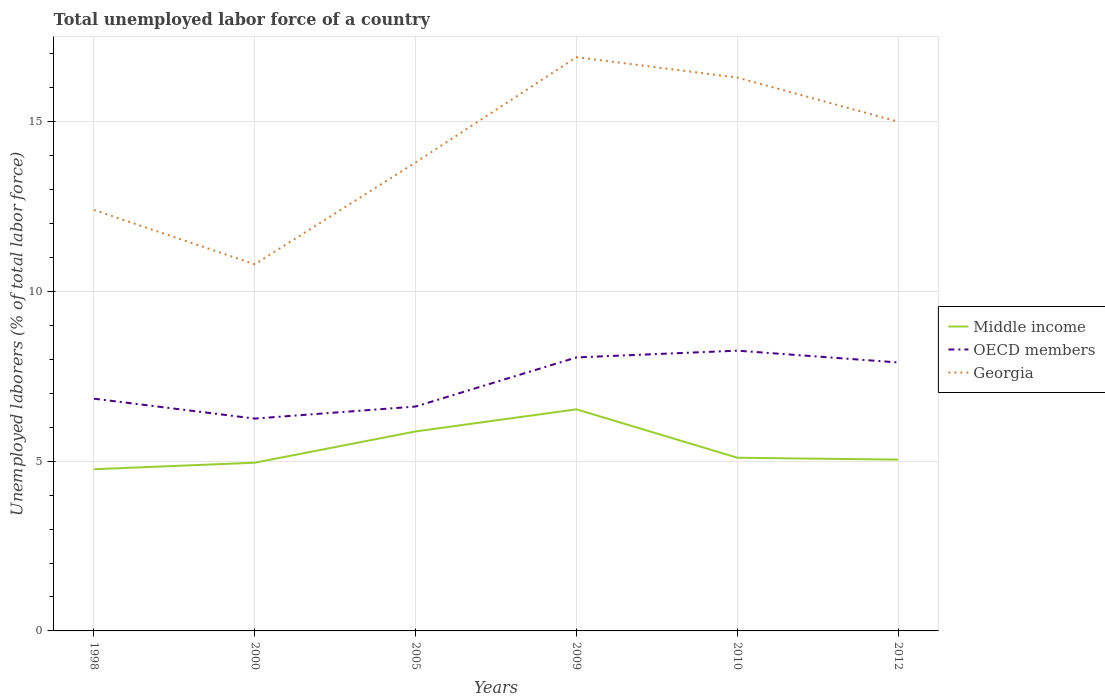Does the line corresponding to OECD members intersect with the line corresponding to Middle income?
Offer a terse response. No. Is the number of lines equal to the number of legend labels?
Make the answer very short. Yes. Across all years, what is the maximum total unemployed labor force in Middle income?
Offer a terse response. 4.76. What is the total total unemployed labor force in Georgia in the graph?
Your answer should be compact. -5.5. What is the difference between the highest and the second highest total unemployed labor force in Middle income?
Offer a terse response. 1.76. What is the difference between two consecutive major ticks on the Y-axis?
Make the answer very short. 5. Are the values on the major ticks of Y-axis written in scientific E-notation?
Your response must be concise. No. Does the graph contain any zero values?
Give a very brief answer. No. How are the legend labels stacked?
Keep it short and to the point. Vertical. What is the title of the graph?
Give a very brief answer. Total unemployed labor force of a country. What is the label or title of the Y-axis?
Ensure brevity in your answer.  Unemployed laborers (% of total labor force). What is the Unemployed laborers (% of total labor force) in Middle income in 1998?
Your answer should be very brief. 4.76. What is the Unemployed laborers (% of total labor force) of OECD members in 1998?
Your response must be concise. 6.84. What is the Unemployed laborers (% of total labor force) of Georgia in 1998?
Provide a succinct answer. 12.4. What is the Unemployed laborers (% of total labor force) of Middle income in 2000?
Give a very brief answer. 4.96. What is the Unemployed laborers (% of total labor force) of OECD members in 2000?
Keep it short and to the point. 6.25. What is the Unemployed laborers (% of total labor force) in Georgia in 2000?
Make the answer very short. 10.8. What is the Unemployed laborers (% of total labor force) in Middle income in 2005?
Offer a terse response. 5.88. What is the Unemployed laborers (% of total labor force) of OECD members in 2005?
Keep it short and to the point. 6.61. What is the Unemployed laborers (% of total labor force) in Georgia in 2005?
Provide a short and direct response. 13.8. What is the Unemployed laborers (% of total labor force) in Middle income in 2009?
Ensure brevity in your answer.  6.53. What is the Unemployed laborers (% of total labor force) in OECD members in 2009?
Ensure brevity in your answer.  8.06. What is the Unemployed laborers (% of total labor force) in Georgia in 2009?
Give a very brief answer. 16.9. What is the Unemployed laborers (% of total labor force) of Middle income in 2010?
Your response must be concise. 5.1. What is the Unemployed laborers (% of total labor force) in OECD members in 2010?
Your response must be concise. 8.26. What is the Unemployed laborers (% of total labor force) in Georgia in 2010?
Offer a very short reply. 16.3. What is the Unemployed laborers (% of total labor force) in Middle income in 2012?
Offer a terse response. 5.05. What is the Unemployed laborers (% of total labor force) in OECD members in 2012?
Ensure brevity in your answer.  7.91. What is the Unemployed laborers (% of total labor force) in Georgia in 2012?
Your response must be concise. 15. Across all years, what is the maximum Unemployed laborers (% of total labor force) in Middle income?
Provide a short and direct response. 6.53. Across all years, what is the maximum Unemployed laborers (% of total labor force) in OECD members?
Provide a succinct answer. 8.26. Across all years, what is the maximum Unemployed laborers (% of total labor force) of Georgia?
Provide a succinct answer. 16.9. Across all years, what is the minimum Unemployed laborers (% of total labor force) of Middle income?
Ensure brevity in your answer.  4.76. Across all years, what is the minimum Unemployed laborers (% of total labor force) in OECD members?
Make the answer very short. 6.25. Across all years, what is the minimum Unemployed laborers (% of total labor force) of Georgia?
Provide a succinct answer. 10.8. What is the total Unemployed laborers (% of total labor force) of Middle income in the graph?
Your answer should be very brief. 32.27. What is the total Unemployed laborers (% of total labor force) in OECD members in the graph?
Offer a terse response. 43.92. What is the total Unemployed laborers (% of total labor force) in Georgia in the graph?
Give a very brief answer. 85.2. What is the difference between the Unemployed laborers (% of total labor force) in Middle income in 1998 and that in 2000?
Give a very brief answer. -0.19. What is the difference between the Unemployed laborers (% of total labor force) of OECD members in 1998 and that in 2000?
Make the answer very short. 0.59. What is the difference between the Unemployed laborers (% of total labor force) of Middle income in 1998 and that in 2005?
Make the answer very short. -1.11. What is the difference between the Unemployed laborers (% of total labor force) in OECD members in 1998 and that in 2005?
Offer a very short reply. 0.23. What is the difference between the Unemployed laborers (% of total labor force) in Georgia in 1998 and that in 2005?
Give a very brief answer. -1.4. What is the difference between the Unemployed laborers (% of total labor force) in Middle income in 1998 and that in 2009?
Make the answer very short. -1.76. What is the difference between the Unemployed laborers (% of total labor force) in OECD members in 1998 and that in 2009?
Provide a succinct answer. -1.22. What is the difference between the Unemployed laborers (% of total labor force) of Middle income in 1998 and that in 2010?
Give a very brief answer. -0.34. What is the difference between the Unemployed laborers (% of total labor force) in OECD members in 1998 and that in 2010?
Offer a terse response. -1.41. What is the difference between the Unemployed laborers (% of total labor force) of Middle income in 1998 and that in 2012?
Offer a very short reply. -0.28. What is the difference between the Unemployed laborers (% of total labor force) in OECD members in 1998 and that in 2012?
Provide a short and direct response. -1.07. What is the difference between the Unemployed laborers (% of total labor force) of Middle income in 2000 and that in 2005?
Provide a succinct answer. -0.92. What is the difference between the Unemployed laborers (% of total labor force) of OECD members in 2000 and that in 2005?
Make the answer very short. -0.35. What is the difference between the Unemployed laborers (% of total labor force) in Georgia in 2000 and that in 2005?
Ensure brevity in your answer.  -3. What is the difference between the Unemployed laborers (% of total labor force) in Middle income in 2000 and that in 2009?
Provide a short and direct response. -1.57. What is the difference between the Unemployed laborers (% of total labor force) in OECD members in 2000 and that in 2009?
Offer a terse response. -1.8. What is the difference between the Unemployed laborers (% of total labor force) in Middle income in 2000 and that in 2010?
Offer a terse response. -0.15. What is the difference between the Unemployed laborers (% of total labor force) in OECD members in 2000 and that in 2010?
Offer a very short reply. -2. What is the difference between the Unemployed laborers (% of total labor force) in Middle income in 2000 and that in 2012?
Your answer should be very brief. -0.09. What is the difference between the Unemployed laborers (% of total labor force) in OECD members in 2000 and that in 2012?
Your answer should be compact. -1.65. What is the difference between the Unemployed laborers (% of total labor force) of Georgia in 2000 and that in 2012?
Provide a short and direct response. -4.2. What is the difference between the Unemployed laborers (% of total labor force) of Middle income in 2005 and that in 2009?
Your answer should be very brief. -0.65. What is the difference between the Unemployed laborers (% of total labor force) of OECD members in 2005 and that in 2009?
Ensure brevity in your answer.  -1.45. What is the difference between the Unemployed laborers (% of total labor force) of Georgia in 2005 and that in 2009?
Ensure brevity in your answer.  -3.1. What is the difference between the Unemployed laborers (% of total labor force) in Middle income in 2005 and that in 2010?
Give a very brief answer. 0.77. What is the difference between the Unemployed laborers (% of total labor force) of OECD members in 2005 and that in 2010?
Ensure brevity in your answer.  -1.65. What is the difference between the Unemployed laborers (% of total labor force) of Middle income in 2005 and that in 2012?
Make the answer very short. 0.83. What is the difference between the Unemployed laborers (% of total labor force) of OECD members in 2005 and that in 2012?
Keep it short and to the point. -1.3. What is the difference between the Unemployed laborers (% of total labor force) of Middle income in 2009 and that in 2010?
Your answer should be very brief. 1.43. What is the difference between the Unemployed laborers (% of total labor force) of OECD members in 2009 and that in 2010?
Provide a short and direct response. -0.2. What is the difference between the Unemployed laborers (% of total labor force) of Middle income in 2009 and that in 2012?
Offer a terse response. 1.48. What is the difference between the Unemployed laborers (% of total labor force) in OECD members in 2009 and that in 2012?
Your answer should be compact. 0.15. What is the difference between the Unemployed laborers (% of total labor force) in Georgia in 2009 and that in 2012?
Give a very brief answer. 1.9. What is the difference between the Unemployed laborers (% of total labor force) of Middle income in 2010 and that in 2012?
Make the answer very short. 0.06. What is the difference between the Unemployed laborers (% of total labor force) of OECD members in 2010 and that in 2012?
Your response must be concise. 0.35. What is the difference between the Unemployed laborers (% of total labor force) of Georgia in 2010 and that in 2012?
Ensure brevity in your answer.  1.3. What is the difference between the Unemployed laborers (% of total labor force) in Middle income in 1998 and the Unemployed laborers (% of total labor force) in OECD members in 2000?
Offer a terse response. -1.49. What is the difference between the Unemployed laborers (% of total labor force) of Middle income in 1998 and the Unemployed laborers (% of total labor force) of Georgia in 2000?
Make the answer very short. -6.04. What is the difference between the Unemployed laborers (% of total labor force) in OECD members in 1998 and the Unemployed laborers (% of total labor force) in Georgia in 2000?
Give a very brief answer. -3.96. What is the difference between the Unemployed laborers (% of total labor force) in Middle income in 1998 and the Unemployed laborers (% of total labor force) in OECD members in 2005?
Your answer should be very brief. -1.85. What is the difference between the Unemployed laborers (% of total labor force) of Middle income in 1998 and the Unemployed laborers (% of total labor force) of Georgia in 2005?
Offer a very short reply. -9.04. What is the difference between the Unemployed laborers (% of total labor force) in OECD members in 1998 and the Unemployed laborers (% of total labor force) in Georgia in 2005?
Offer a terse response. -6.96. What is the difference between the Unemployed laborers (% of total labor force) in Middle income in 1998 and the Unemployed laborers (% of total labor force) in OECD members in 2009?
Provide a short and direct response. -3.29. What is the difference between the Unemployed laborers (% of total labor force) in Middle income in 1998 and the Unemployed laborers (% of total labor force) in Georgia in 2009?
Provide a short and direct response. -12.14. What is the difference between the Unemployed laborers (% of total labor force) in OECD members in 1998 and the Unemployed laborers (% of total labor force) in Georgia in 2009?
Your answer should be very brief. -10.06. What is the difference between the Unemployed laborers (% of total labor force) of Middle income in 1998 and the Unemployed laborers (% of total labor force) of OECD members in 2010?
Your answer should be compact. -3.49. What is the difference between the Unemployed laborers (% of total labor force) in Middle income in 1998 and the Unemployed laborers (% of total labor force) in Georgia in 2010?
Make the answer very short. -11.54. What is the difference between the Unemployed laborers (% of total labor force) in OECD members in 1998 and the Unemployed laborers (% of total labor force) in Georgia in 2010?
Provide a short and direct response. -9.46. What is the difference between the Unemployed laborers (% of total labor force) in Middle income in 1998 and the Unemployed laborers (% of total labor force) in OECD members in 2012?
Keep it short and to the point. -3.14. What is the difference between the Unemployed laborers (% of total labor force) in Middle income in 1998 and the Unemployed laborers (% of total labor force) in Georgia in 2012?
Offer a very short reply. -10.24. What is the difference between the Unemployed laborers (% of total labor force) of OECD members in 1998 and the Unemployed laborers (% of total labor force) of Georgia in 2012?
Offer a terse response. -8.16. What is the difference between the Unemployed laborers (% of total labor force) in Middle income in 2000 and the Unemployed laborers (% of total labor force) in OECD members in 2005?
Your answer should be compact. -1.65. What is the difference between the Unemployed laborers (% of total labor force) in Middle income in 2000 and the Unemployed laborers (% of total labor force) in Georgia in 2005?
Your answer should be compact. -8.85. What is the difference between the Unemployed laborers (% of total labor force) in OECD members in 2000 and the Unemployed laborers (% of total labor force) in Georgia in 2005?
Provide a short and direct response. -7.55. What is the difference between the Unemployed laborers (% of total labor force) in Middle income in 2000 and the Unemployed laborers (% of total labor force) in OECD members in 2009?
Make the answer very short. -3.1. What is the difference between the Unemployed laborers (% of total labor force) in Middle income in 2000 and the Unemployed laborers (% of total labor force) in Georgia in 2009?
Give a very brief answer. -11.95. What is the difference between the Unemployed laborers (% of total labor force) in OECD members in 2000 and the Unemployed laborers (% of total labor force) in Georgia in 2009?
Offer a terse response. -10.65. What is the difference between the Unemployed laborers (% of total labor force) in Middle income in 2000 and the Unemployed laborers (% of total labor force) in OECD members in 2010?
Keep it short and to the point. -3.3. What is the difference between the Unemployed laborers (% of total labor force) in Middle income in 2000 and the Unemployed laborers (% of total labor force) in Georgia in 2010?
Keep it short and to the point. -11.35. What is the difference between the Unemployed laborers (% of total labor force) of OECD members in 2000 and the Unemployed laborers (% of total labor force) of Georgia in 2010?
Make the answer very short. -10.05. What is the difference between the Unemployed laborers (% of total labor force) in Middle income in 2000 and the Unemployed laborers (% of total labor force) in OECD members in 2012?
Provide a short and direct response. -2.95. What is the difference between the Unemployed laborers (% of total labor force) of Middle income in 2000 and the Unemployed laborers (% of total labor force) of Georgia in 2012?
Offer a very short reply. -10.04. What is the difference between the Unemployed laborers (% of total labor force) in OECD members in 2000 and the Unemployed laborers (% of total labor force) in Georgia in 2012?
Offer a terse response. -8.75. What is the difference between the Unemployed laborers (% of total labor force) of Middle income in 2005 and the Unemployed laborers (% of total labor force) of OECD members in 2009?
Provide a succinct answer. -2.18. What is the difference between the Unemployed laborers (% of total labor force) in Middle income in 2005 and the Unemployed laborers (% of total labor force) in Georgia in 2009?
Your response must be concise. -11.02. What is the difference between the Unemployed laborers (% of total labor force) of OECD members in 2005 and the Unemployed laborers (% of total labor force) of Georgia in 2009?
Provide a succinct answer. -10.29. What is the difference between the Unemployed laborers (% of total labor force) in Middle income in 2005 and the Unemployed laborers (% of total labor force) in OECD members in 2010?
Provide a short and direct response. -2.38. What is the difference between the Unemployed laborers (% of total labor force) in Middle income in 2005 and the Unemployed laborers (% of total labor force) in Georgia in 2010?
Your answer should be compact. -10.42. What is the difference between the Unemployed laborers (% of total labor force) in OECD members in 2005 and the Unemployed laborers (% of total labor force) in Georgia in 2010?
Give a very brief answer. -9.69. What is the difference between the Unemployed laborers (% of total labor force) of Middle income in 2005 and the Unemployed laborers (% of total labor force) of OECD members in 2012?
Make the answer very short. -2.03. What is the difference between the Unemployed laborers (% of total labor force) of Middle income in 2005 and the Unemployed laborers (% of total labor force) of Georgia in 2012?
Ensure brevity in your answer.  -9.12. What is the difference between the Unemployed laborers (% of total labor force) in OECD members in 2005 and the Unemployed laborers (% of total labor force) in Georgia in 2012?
Provide a short and direct response. -8.39. What is the difference between the Unemployed laborers (% of total labor force) in Middle income in 2009 and the Unemployed laborers (% of total labor force) in OECD members in 2010?
Make the answer very short. -1.73. What is the difference between the Unemployed laborers (% of total labor force) in Middle income in 2009 and the Unemployed laborers (% of total labor force) in Georgia in 2010?
Ensure brevity in your answer.  -9.77. What is the difference between the Unemployed laborers (% of total labor force) in OECD members in 2009 and the Unemployed laborers (% of total labor force) in Georgia in 2010?
Offer a very short reply. -8.24. What is the difference between the Unemployed laborers (% of total labor force) of Middle income in 2009 and the Unemployed laborers (% of total labor force) of OECD members in 2012?
Offer a terse response. -1.38. What is the difference between the Unemployed laborers (% of total labor force) in Middle income in 2009 and the Unemployed laborers (% of total labor force) in Georgia in 2012?
Your response must be concise. -8.47. What is the difference between the Unemployed laborers (% of total labor force) in OECD members in 2009 and the Unemployed laborers (% of total labor force) in Georgia in 2012?
Give a very brief answer. -6.94. What is the difference between the Unemployed laborers (% of total labor force) of Middle income in 2010 and the Unemployed laborers (% of total labor force) of OECD members in 2012?
Keep it short and to the point. -2.81. What is the difference between the Unemployed laborers (% of total labor force) of Middle income in 2010 and the Unemployed laborers (% of total labor force) of Georgia in 2012?
Provide a short and direct response. -9.9. What is the difference between the Unemployed laborers (% of total labor force) of OECD members in 2010 and the Unemployed laborers (% of total labor force) of Georgia in 2012?
Provide a succinct answer. -6.74. What is the average Unemployed laborers (% of total labor force) in Middle income per year?
Make the answer very short. 5.38. What is the average Unemployed laborers (% of total labor force) in OECD members per year?
Your answer should be very brief. 7.32. What is the average Unemployed laborers (% of total labor force) in Georgia per year?
Make the answer very short. 14.2. In the year 1998, what is the difference between the Unemployed laborers (% of total labor force) of Middle income and Unemployed laborers (% of total labor force) of OECD members?
Provide a short and direct response. -2.08. In the year 1998, what is the difference between the Unemployed laborers (% of total labor force) in Middle income and Unemployed laborers (% of total labor force) in Georgia?
Your answer should be very brief. -7.64. In the year 1998, what is the difference between the Unemployed laborers (% of total labor force) of OECD members and Unemployed laborers (% of total labor force) of Georgia?
Your response must be concise. -5.56. In the year 2000, what is the difference between the Unemployed laborers (% of total labor force) of Middle income and Unemployed laborers (% of total labor force) of OECD members?
Ensure brevity in your answer.  -1.3. In the year 2000, what is the difference between the Unemployed laborers (% of total labor force) in Middle income and Unemployed laborers (% of total labor force) in Georgia?
Your answer should be very brief. -5.84. In the year 2000, what is the difference between the Unemployed laborers (% of total labor force) in OECD members and Unemployed laborers (% of total labor force) in Georgia?
Keep it short and to the point. -4.55. In the year 2005, what is the difference between the Unemployed laborers (% of total labor force) of Middle income and Unemployed laborers (% of total labor force) of OECD members?
Provide a short and direct response. -0.73. In the year 2005, what is the difference between the Unemployed laborers (% of total labor force) of Middle income and Unemployed laborers (% of total labor force) of Georgia?
Your response must be concise. -7.92. In the year 2005, what is the difference between the Unemployed laborers (% of total labor force) in OECD members and Unemployed laborers (% of total labor force) in Georgia?
Offer a terse response. -7.19. In the year 2009, what is the difference between the Unemployed laborers (% of total labor force) in Middle income and Unemployed laborers (% of total labor force) in OECD members?
Give a very brief answer. -1.53. In the year 2009, what is the difference between the Unemployed laborers (% of total labor force) of Middle income and Unemployed laborers (% of total labor force) of Georgia?
Make the answer very short. -10.37. In the year 2009, what is the difference between the Unemployed laborers (% of total labor force) of OECD members and Unemployed laborers (% of total labor force) of Georgia?
Your answer should be compact. -8.84. In the year 2010, what is the difference between the Unemployed laborers (% of total labor force) in Middle income and Unemployed laborers (% of total labor force) in OECD members?
Offer a very short reply. -3.15. In the year 2010, what is the difference between the Unemployed laborers (% of total labor force) in Middle income and Unemployed laborers (% of total labor force) in Georgia?
Offer a terse response. -11.2. In the year 2010, what is the difference between the Unemployed laborers (% of total labor force) of OECD members and Unemployed laborers (% of total labor force) of Georgia?
Provide a succinct answer. -8.04. In the year 2012, what is the difference between the Unemployed laborers (% of total labor force) in Middle income and Unemployed laborers (% of total labor force) in OECD members?
Offer a very short reply. -2.86. In the year 2012, what is the difference between the Unemployed laborers (% of total labor force) in Middle income and Unemployed laborers (% of total labor force) in Georgia?
Give a very brief answer. -9.95. In the year 2012, what is the difference between the Unemployed laborers (% of total labor force) in OECD members and Unemployed laborers (% of total labor force) in Georgia?
Keep it short and to the point. -7.09. What is the ratio of the Unemployed laborers (% of total labor force) of Middle income in 1998 to that in 2000?
Offer a terse response. 0.96. What is the ratio of the Unemployed laborers (% of total labor force) of OECD members in 1998 to that in 2000?
Provide a short and direct response. 1.09. What is the ratio of the Unemployed laborers (% of total labor force) in Georgia in 1998 to that in 2000?
Offer a terse response. 1.15. What is the ratio of the Unemployed laborers (% of total labor force) of Middle income in 1998 to that in 2005?
Ensure brevity in your answer.  0.81. What is the ratio of the Unemployed laborers (% of total labor force) in OECD members in 1998 to that in 2005?
Provide a short and direct response. 1.03. What is the ratio of the Unemployed laborers (% of total labor force) in Georgia in 1998 to that in 2005?
Provide a short and direct response. 0.9. What is the ratio of the Unemployed laborers (% of total labor force) in Middle income in 1998 to that in 2009?
Make the answer very short. 0.73. What is the ratio of the Unemployed laborers (% of total labor force) of OECD members in 1998 to that in 2009?
Your answer should be compact. 0.85. What is the ratio of the Unemployed laborers (% of total labor force) of Georgia in 1998 to that in 2009?
Give a very brief answer. 0.73. What is the ratio of the Unemployed laborers (% of total labor force) of Middle income in 1998 to that in 2010?
Your answer should be very brief. 0.93. What is the ratio of the Unemployed laborers (% of total labor force) in OECD members in 1998 to that in 2010?
Offer a terse response. 0.83. What is the ratio of the Unemployed laborers (% of total labor force) of Georgia in 1998 to that in 2010?
Offer a very short reply. 0.76. What is the ratio of the Unemployed laborers (% of total labor force) in Middle income in 1998 to that in 2012?
Offer a terse response. 0.94. What is the ratio of the Unemployed laborers (% of total labor force) of OECD members in 1998 to that in 2012?
Offer a terse response. 0.87. What is the ratio of the Unemployed laborers (% of total labor force) of Georgia in 1998 to that in 2012?
Provide a short and direct response. 0.83. What is the ratio of the Unemployed laborers (% of total labor force) of Middle income in 2000 to that in 2005?
Your answer should be compact. 0.84. What is the ratio of the Unemployed laborers (% of total labor force) of OECD members in 2000 to that in 2005?
Your answer should be very brief. 0.95. What is the ratio of the Unemployed laborers (% of total labor force) in Georgia in 2000 to that in 2005?
Keep it short and to the point. 0.78. What is the ratio of the Unemployed laborers (% of total labor force) in Middle income in 2000 to that in 2009?
Offer a terse response. 0.76. What is the ratio of the Unemployed laborers (% of total labor force) of OECD members in 2000 to that in 2009?
Ensure brevity in your answer.  0.78. What is the ratio of the Unemployed laborers (% of total labor force) in Georgia in 2000 to that in 2009?
Your response must be concise. 0.64. What is the ratio of the Unemployed laborers (% of total labor force) of Middle income in 2000 to that in 2010?
Provide a succinct answer. 0.97. What is the ratio of the Unemployed laborers (% of total labor force) in OECD members in 2000 to that in 2010?
Provide a succinct answer. 0.76. What is the ratio of the Unemployed laborers (% of total labor force) of Georgia in 2000 to that in 2010?
Keep it short and to the point. 0.66. What is the ratio of the Unemployed laborers (% of total labor force) in Middle income in 2000 to that in 2012?
Ensure brevity in your answer.  0.98. What is the ratio of the Unemployed laborers (% of total labor force) of OECD members in 2000 to that in 2012?
Provide a short and direct response. 0.79. What is the ratio of the Unemployed laborers (% of total labor force) in Georgia in 2000 to that in 2012?
Offer a very short reply. 0.72. What is the ratio of the Unemployed laborers (% of total labor force) of Middle income in 2005 to that in 2009?
Offer a very short reply. 0.9. What is the ratio of the Unemployed laborers (% of total labor force) of OECD members in 2005 to that in 2009?
Provide a short and direct response. 0.82. What is the ratio of the Unemployed laborers (% of total labor force) in Georgia in 2005 to that in 2009?
Offer a terse response. 0.82. What is the ratio of the Unemployed laborers (% of total labor force) of Middle income in 2005 to that in 2010?
Provide a short and direct response. 1.15. What is the ratio of the Unemployed laborers (% of total labor force) of OECD members in 2005 to that in 2010?
Give a very brief answer. 0.8. What is the ratio of the Unemployed laborers (% of total labor force) in Georgia in 2005 to that in 2010?
Offer a terse response. 0.85. What is the ratio of the Unemployed laborers (% of total labor force) of Middle income in 2005 to that in 2012?
Provide a short and direct response. 1.16. What is the ratio of the Unemployed laborers (% of total labor force) of OECD members in 2005 to that in 2012?
Your answer should be very brief. 0.84. What is the ratio of the Unemployed laborers (% of total labor force) in Middle income in 2009 to that in 2010?
Provide a short and direct response. 1.28. What is the ratio of the Unemployed laborers (% of total labor force) of OECD members in 2009 to that in 2010?
Provide a succinct answer. 0.98. What is the ratio of the Unemployed laborers (% of total labor force) in Georgia in 2009 to that in 2010?
Your response must be concise. 1.04. What is the ratio of the Unemployed laborers (% of total labor force) in Middle income in 2009 to that in 2012?
Offer a very short reply. 1.29. What is the ratio of the Unemployed laborers (% of total labor force) in OECD members in 2009 to that in 2012?
Keep it short and to the point. 1.02. What is the ratio of the Unemployed laborers (% of total labor force) in Georgia in 2009 to that in 2012?
Give a very brief answer. 1.13. What is the ratio of the Unemployed laborers (% of total labor force) of Middle income in 2010 to that in 2012?
Provide a short and direct response. 1.01. What is the ratio of the Unemployed laborers (% of total labor force) of OECD members in 2010 to that in 2012?
Your answer should be very brief. 1.04. What is the ratio of the Unemployed laborers (% of total labor force) of Georgia in 2010 to that in 2012?
Provide a short and direct response. 1.09. What is the difference between the highest and the second highest Unemployed laborers (% of total labor force) in Middle income?
Give a very brief answer. 0.65. What is the difference between the highest and the second highest Unemployed laborers (% of total labor force) in OECD members?
Make the answer very short. 0.2. What is the difference between the highest and the lowest Unemployed laborers (% of total labor force) of Middle income?
Your answer should be compact. 1.76. What is the difference between the highest and the lowest Unemployed laborers (% of total labor force) in OECD members?
Provide a succinct answer. 2. What is the difference between the highest and the lowest Unemployed laborers (% of total labor force) of Georgia?
Ensure brevity in your answer.  6.1. 